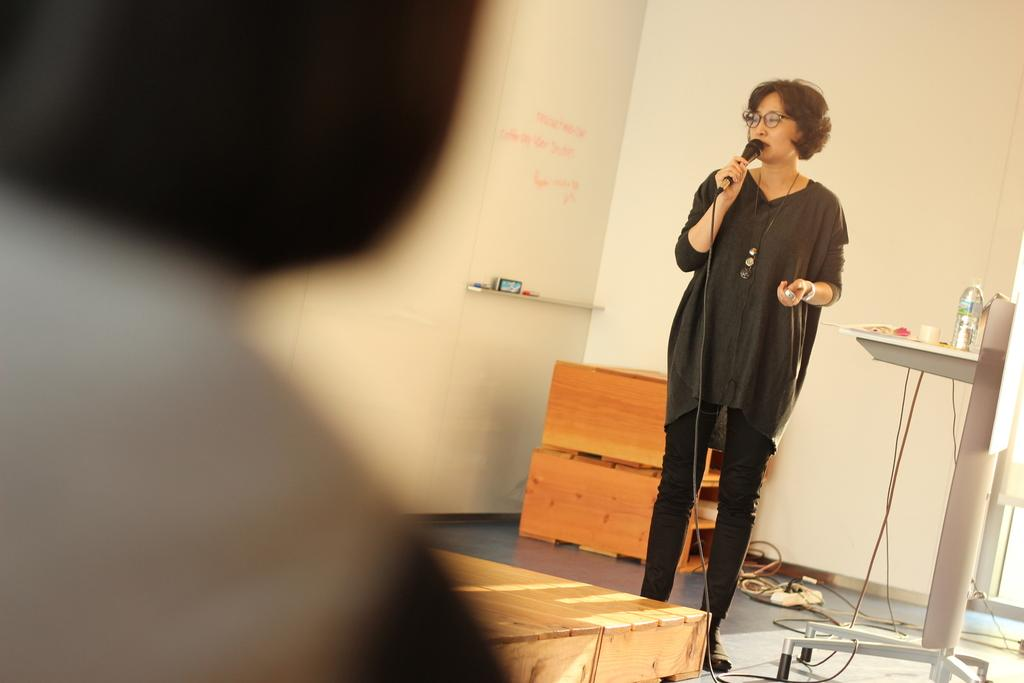Who is the main subject in the image? There is a woman in the image. What is the woman doing in the image? The woman is standing and speaking into a microphone. What can be seen on the floor in the image? There are objects placed on the floor in the image. Where is the object located in relation to the woman? There is an object on the left side of the image. How many geese are flying over the woman in the image? There are no geese present in the image. Is the woman participating in a battle in the image? There is no indication of a battle in the image; the woman is speaking into a microphone. 